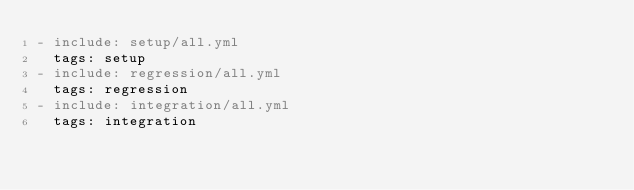<code> <loc_0><loc_0><loc_500><loc_500><_YAML_>- include: setup/all.yml
  tags: setup
- include: regression/all.yml
  tags: regression
- include: integration/all.yml
  tags: integration
</code> 